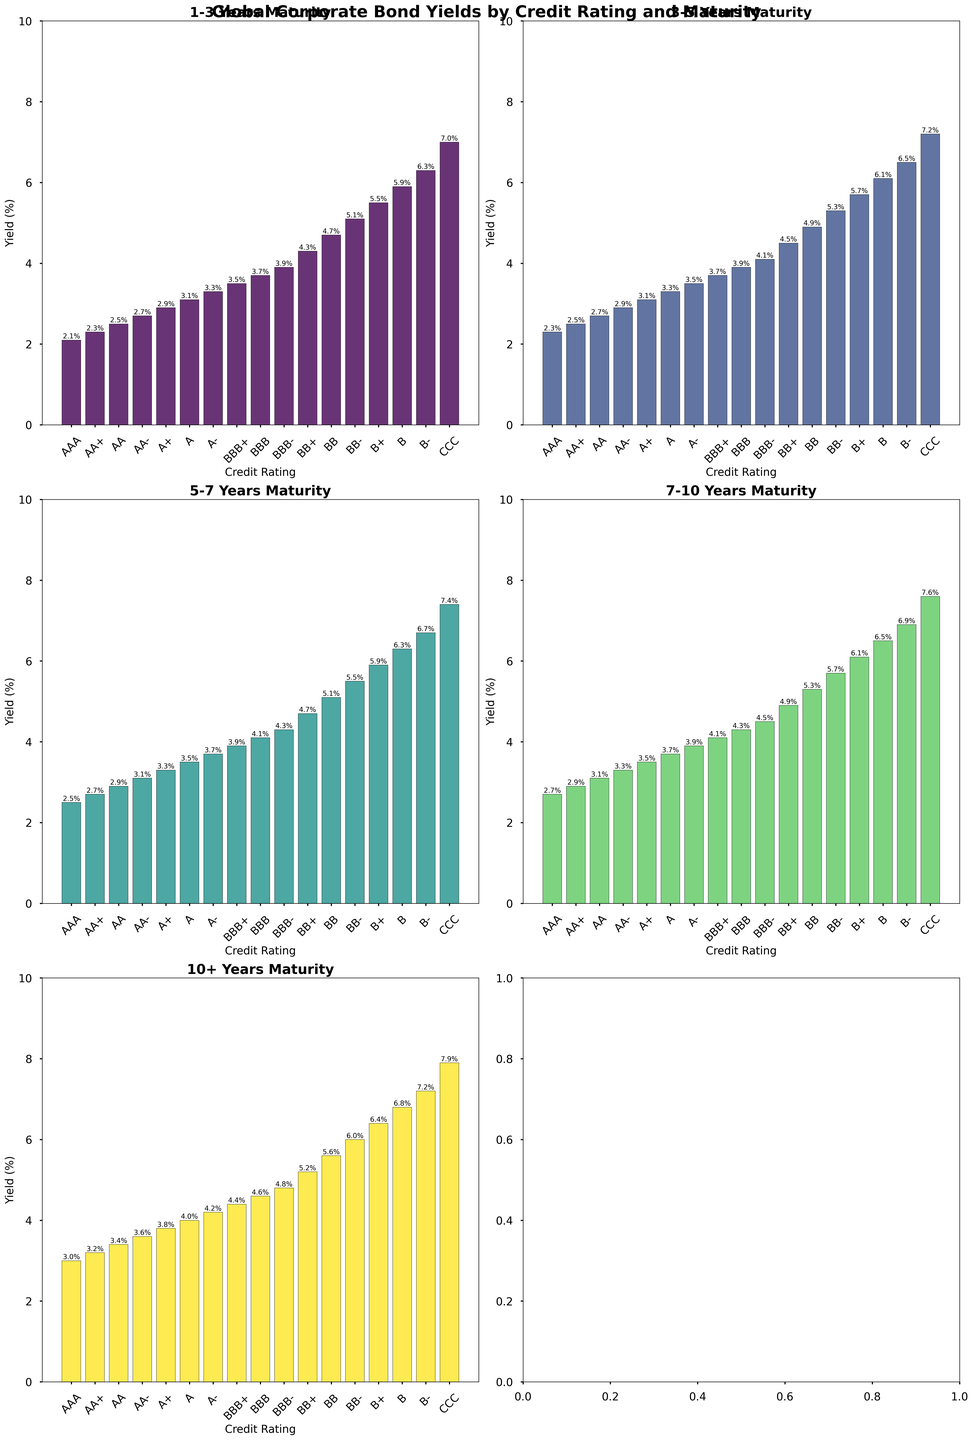What's the yield of BBB rated bonds with a maturity of 10+ years? Look at the subplot for 10+ Years maturity, find the bar labeled "BBB", and read the yield value.
Answer: 4.6% Which bond rating has the lowest yield for 5-7 years maturity, and what is its yield? Look at the subplot for 5-7 Years maturity, and find the bar with the lowest height, which corresponds to the lowest yield. The bar labeled "AAA" is the lowest.
Answer: AAA, 2.5% Compare the yields of AA- rated bonds with maturities of 3-5 years and 7-10 years. Which one is higher and by how much? Look at the subplot for 3-5 Years maturity for AA- rated bonds and note the yield (2.9%). Then look at the subplot for 7-10 Years maturity and note the yield for the same rating (3.3%). Subtract the smaller yield from the larger one to find the difference.
Answer: 7-10 Years is higher by 0.4% Which rating has a more significant difference in yield between 1-3 years and 7-10 years maturities, A+ or BBB+? What is the difference in each case? Check the yield values of A+ for 1-3 years (2.9%) and 7-10 years (3.5%), then find the difference (3.5% - 2.9% = 0.6%). Similarly, check BBB+ for 1-3 years (3.5%) and 7-10 years (4.1%), then find the difference (4.1% - 3.5% = 0.6%). Both have the same difference, so they are equal.
Answer: Both are equal, 0.6% What is the average yield of AA rated bonds across all maturity periods? Add the yields of AA rated bonds for all maturity periods (2.5%, 2.7%, 2.9%, 3.1%, 3.4%) and divide by the number of periods (5). (2.5 + 2.7 + 2.9 + 3.1 + 3.4) / 5 = 14.6 / 5
Answer: 2.92% For the CCC rated bonds, how much higher is the yield for 10+ years maturity compared to 1-3 years maturity? Find the yield values for CCC rated bonds for 1-3 years (7.0%) and 10+ years (7.9%). Subtract the 1-3 years yield from the 10+ years yield (7.9% - 7.0%).
Answer: 0.9% Identify the trend in yields as maturity period increases for AA+ rated bonds. Look at the yields for AA+ across all maturity subplots: 1-3 years (2.3%), 3-5 years (2.5%), 5-7 years (2.7%), 7-10 years (2.9%), and 10+ years (3.2%). The yield increases with increasing maturity.
Answer: Increasing Which credit rating is closest to having equal yields for 3-5 years and 5-7 years maturities? Compare the yields of all ratings for these maturity periods and find the pair with nearly identical values. The yields for "BBB" are 3.9% for both 3-5 years and 5-7 years.
Answer: BBB For AA- rated bonds, what is the sum of yields for all maturities? Add the yields for AA- rated bonds across all maturities: 2.7% (1-3 years), 2.9% (3-5 years), 3.1% (5-7 years), 3.3% (7-10 years), 3.6% (10+ years). (2.7 + 2.9 + 3.1 + 3.3 + 3.6) = 15.6
Answer: 15.6 